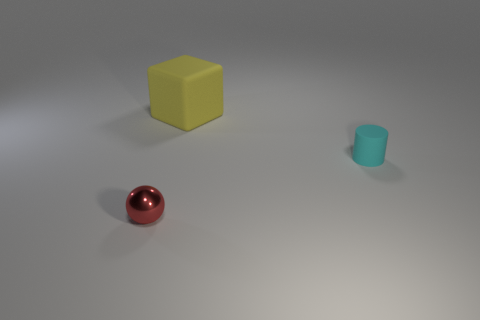Add 1 yellow objects. How many yellow objects exist? 2 Add 1 tiny rubber things. How many objects exist? 4 Subtract 0 yellow balls. How many objects are left? 3 Subtract all purple spheres. Subtract all cyan blocks. How many spheres are left? 1 Subtract all brown cubes. How many purple cylinders are left? 0 Subtract all rubber things. Subtract all small gray rubber things. How many objects are left? 1 Add 1 red objects. How many red objects are left? 2 